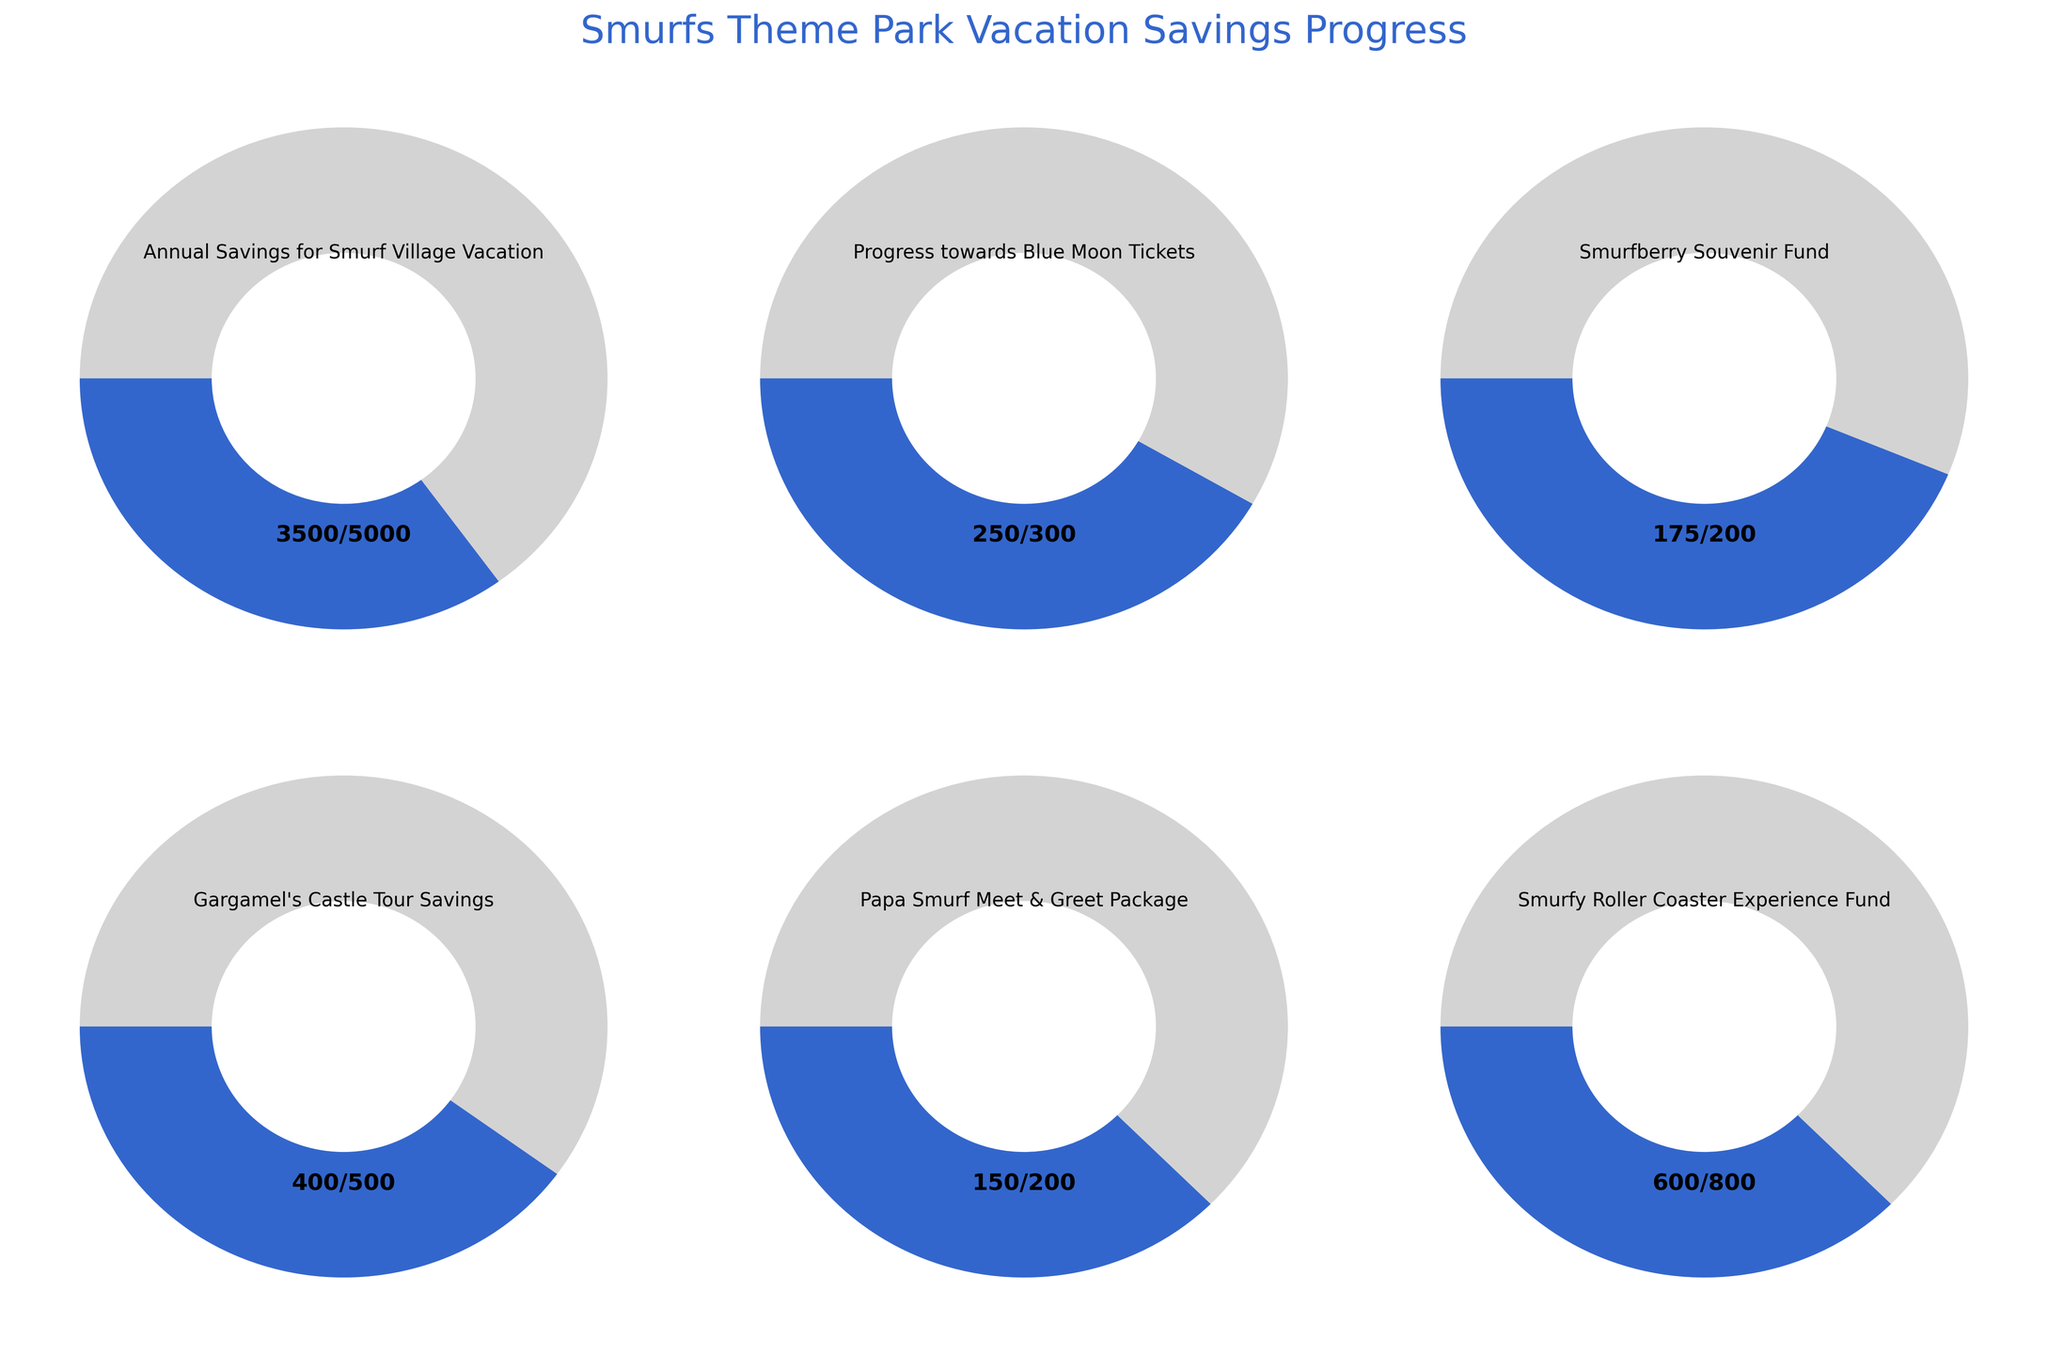What is the title of the figure? The title is located at the top of the figure and reads "Smurfs Theme Park Vacation Savings Progress".
Answer: Smurfs Theme Park Vacation Savings Progress How much have you saved for the Annual Savings for Smurf Village Vacation? The gauge at the top left shows "3500/5000", indicating the current savings amount out of the goal.
Answer: 3500 Which fund has the lowest savings progress? Comparing the progress in all gauges, the "Papa Smurf Meet & Greet Package" shows "150/200", which is the minimum progress in terms of both absolute and relative amounts.
Answer: Papa Smurf Meet & Greet Package What is the proportion of savings achieved for the Smurfy Roller Coaster Experience Fund? The gauge shows "600/800". To find the proportion, divide 600 by 800.
Answer: 0.75 If you sum the maximum goals of all funds, what is the total amount? To calculate the total, add the maximum values: 5000 + 300 + 200 + 500 + 200 + 800 = 7000.
Answer: 7000 How does the progress of the Annual Savings for Smurf Village Vacation compare to Gargamel's Castle Tour Savings? The savings for the Smurf Village Vacation is "3500/5000" and for Gargamel's Castle Tour it's "400/500". By comparing the percentages, 3500/5000 = 0.7 and 400/500 = 0.8, indicating Gargamel's Castle Tour Savings has a higher completion percentage.
Answer: Gargamel's Castle Tour Savings Which gauge shows the most significant progress towards its goal in percentage terms? By comparing the percentages, "Smurfberry Souvenir Fund" has "175/200", which is the highest proportion, calculated as 175/200 = 0.875 or 87.5%.
Answer: Smurfberry Souvenir Fund What percentage of the Blue Moon Tickets fund has been saved? The gauge shows "250/300", so to find the percentage, calculate (250/300) * 100 = 83.33%.
Answer: 83.33% How much more is needed to reach the goal for Gargamel's Castle Tour Savings? The gauge for Gargamel's Castle Tour shows "400/500". To find the remaining amount, subtract the current savings from the goal: 500 - 400 = 100.
Answer: 100 Which fund is closest to reaching its goal? By comparing the remaining amounts needed, the "Smurfberry Souvenir Fund" with "175/200" is the closest, needing only 25 more to reach its goal.
Answer: Smurfberry Souvenir Fund 